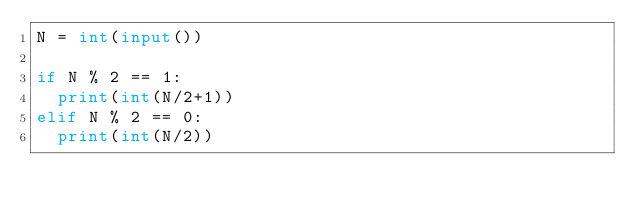Convert code to text. <code><loc_0><loc_0><loc_500><loc_500><_Python_>N = int(input())

if N % 2 == 1:
  print(int(N/2+1))
elif N % 2 == 0:
  print(int(N/2))</code> 